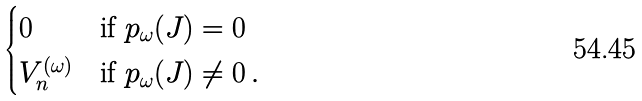Convert formula to latex. <formula><loc_0><loc_0><loc_500><loc_500>\begin{cases} 0 & \text {if } p _ { \omega } ( J ) = 0 \\ V _ { n } ^ { ( \omega ) } & \text {if } p _ { \omega } ( J ) \neq 0 \, . \end{cases}</formula> 